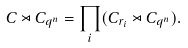Convert formula to latex. <formula><loc_0><loc_0><loc_500><loc_500>C \rtimes C _ { q ^ { n } } = \prod _ { i } ( C _ { r _ { i } } \rtimes C _ { q ^ { n } } ) .</formula> 